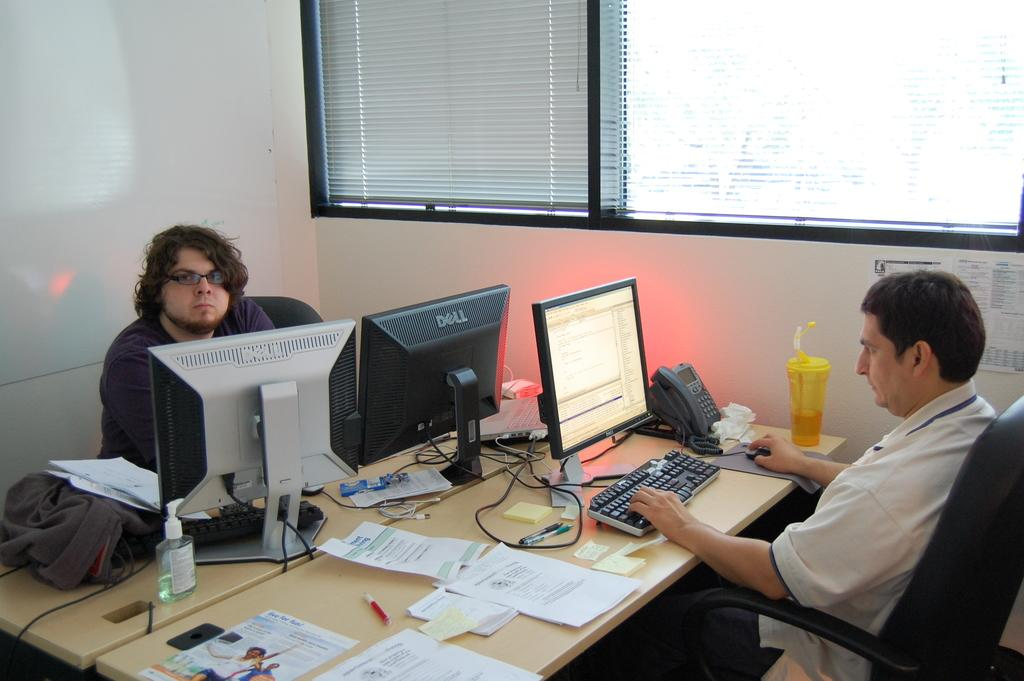<image>
Summarize the visual content of the image. Man is sitting in front of a computer monitor that says DELL. 